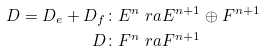Convert formula to latex. <formula><loc_0><loc_0><loc_500><loc_500>D = D _ { e } + D _ { f } & \colon E ^ { n } \ r a E ^ { n + 1 } \oplus F ^ { n + 1 } \\ D & \colon F ^ { n } \ r a F ^ { n + 1 }</formula> 